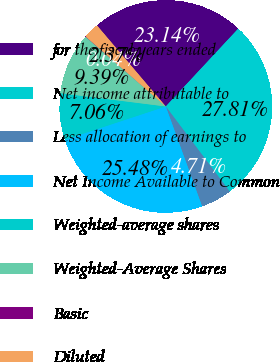Convert chart to OTSL. <chart><loc_0><loc_0><loc_500><loc_500><pie_chart><fcel>for the fiscal years ended<fcel>Net income attributable to<fcel>Less allocation of earnings to<fcel>Net Income Available to Common<fcel>Weighted-average shares<fcel>Weighted-Average Shares<fcel>Basic<fcel>Diluted<nl><fcel>23.14%<fcel>27.81%<fcel>4.71%<fcel>25.48%<fcel>7.06%<fcel>9.39%<fcel>0.04%<fcel>2.37%<nl></chart> 